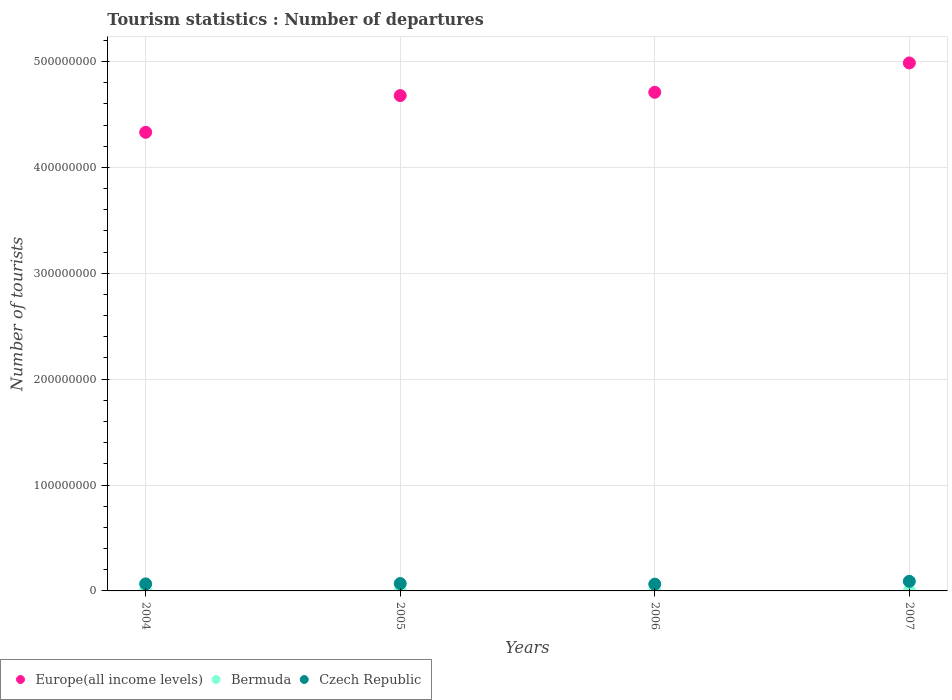How many different coloured dotlines are there?
Your response must be concise. 3. Is the number of dotlines equal to the number of legend labels?
Your answer should be very brief. Yes. What is the number of tourist departures in Europe(all income levels) in 2007?
Provide a short and direct response. 4.99e+08. Across all years, what is the maximum number of tourist departures in Bermuda?
Give a very brief answer. 1.81e+05. Across all years, what is the minimum number of tourist departures in Europe(all income levels)?
Make the answer very short. 4.33e+08. In which year was the number of tourist departures in Czech Republic maximum?
Provide a succinct answer. 2007. In which year was the number of tourist departures in Europe(all income levels) minimum?
Ensure brevity in your answer.  2004. What is the total number of tourist departures in Europe(all income levels) in the graph?
Ensure brevity in your answer.  1.87e+09. What is the difference between the number of tourist departures in Bermuda in 2004 and that in 2006?
Offer a very short reply. -1.40e+04. What is the difference between the number of tourist departures in Czech Republic in 2006 and the number of tourist departures in Bermuda in 2005?
Make the answer very short. 6.23e+06. What is the average number of tourist departures in Bermuda per year?
Your answer should be compact. 1.67e+05. In the year 2005, what is the difference between the number of tourist departures in Bermuda and number of tourist departures in Czech Republic?
Your answer should be compact. -6.80e+06. In how many years, is the number of tourist departures in Bermuda greater than 120000000?
Offer a very short reply. 0. What is the ratio of the number of tourist departures in Europe(all income levels) in 2005 to that in 2007?
Keep it short and to the point. 0.94. Is the difference between the number of tourist departures in Bermuda in 2005 and 2006 greater than the difference between the number of tourist departures in Czech Republic in 2005 and 2006?
Give a very brief answer. No. What is the difference between the highest and the second highest number of tourist departures in Bermuda?
Keep it short and to the point. 1.10e+04. What is the difference between the highest and the lowest number of tourist departures in Czech Republic?
Provide a succinct answer. 2.66e+06. In how many years, is the number of tourist departures in Czech Republic greater than the average number of tourist departures in Czech Republic taken over all years?
Give a very brief answer. 1. Is the sum of the number of tourist departures in Bermuda in 2005 and 2006 greater than the maximum number of tourist departures in Czech Republic across all years?
Provide a succinct answer. No. Is the number of tourist departures in Czech Republic strictly less than the number of tourist departures in Bermuda over the years?
Ensure brevity in your answer.  No. How many years are there in the graph?
Provide a short and direct response. 4. What is the difference between two consecutive major ticks on the Y-axis?
Make the answer very short. 1.00e+08. Does the graph contain grids?
Give a very brief answer. Yes. Where does the legend appear in the graph?
Your response must be concise. Bottom left. What is the title of the graph?
Provide a succinct answer. Tourism statistics : Number of departures. What is the label or title of the Y-axis?
Make the answer very short. Number of tourists. What is the Number of tourists in Europe(all income levels) in 2004?
Provide a short and direct response. 4.33e+08. What is the Number of tourists in Bermuda in 2004?
Offer a very short reply. 1.56e+05. What is the Number of tourists of Czech Republic in 2004?
Make the answer very short. 6.64e+06. What is the Number of tourists of Europe(all income levels) in 2005?
Provide a short and direct response. 4.68e+08. What is the Number of tourists of Bermuda in 2005?
Make the answer very short. 1.61e+05. What is the Number of tourists in Czech Republic in 2005?
Make the answer very short. 6.96e+06. What is the Number of tourists of Europe(all income levels) in 2006?
Offer a terse response. 4.71e+08. What is the Number of tourists in Czech Republic in 2006?
Ensure brevity in your answer.  6.39e+06. What is the Number of tourists of Europe(all income levels) in 2007?
Ensure brevity in your answer.  4.99e+08. What is the Number of tourists of Bermuda in 2007?
Your answer should be compact. 1.81e+05. What is the Number of tourists of Czech Republic in 2007?
Provide a short and direct response. 9.05e+06. Across all years, what is the maximum Number of tourists in Europe(all income levels)?
Offer a terse response. 4.99e+08. Across all years, what is the maximum Number of tourists of Bermuda?
Provide a short and direct response. 1.81e+05. Across all years, what is the maximum Number of tourists in Czech Republic?
Provide a succinct answer. 9.05e+06. Across all years, what is the minimum Number of tourists of Europe(all income levels)?
Your answer should be very brief. 4.33e+08. Across all years, what is the minimum Number of tourists of Bermuda?
Ensure brevity in your answer.  1.56e+05. Across all years, what is the minimum Number of tourists of Czech Republic?
Provide a short and direct response. 6.39e+06. What is the total Number of tourists in Europe(all income levels) in the graph?
Your answer should be compact. 1.87e+09. What is the total Number of tourists of Bermuda in the graph?
Your answer should be very brief. 6.68e+05. What is the total Number of tourists of Czech Republic in the graph?
Your answer should be compact. 2.90e+07. What is the difference between the Number of tourists of Europe(all income levels) in 2004 and that in 2005?
Provide a succinct answer. -3.47e+07. What is the difference between the Number of tourists of Bermuda in 2004 and that in 2005?
Offer a very short reply. -5000. What is the difference between the Number of tourists of Czech Republic in 2004 and that in 2005?
Offer a very short reply. -3.20e+05. What is the difference between the Number of tourists of Europe(all income levels) in 2004 and that in 2006?
Give a very brief answer. -3.78e+07. What is the difference between the Number of tourists in Bermuda in 2004 and that in 2006?
Give a very brief answer. -1.40e+04. What is the difference between the Number of tourists of Czech Republic in 2004 and that in 2006?
Ensure brevity in your answer.  2.50e+05. What is the difference between the Number of tourists of Europe(all income levels) in 2004 and that in 2007?
Provide a short and direct response. -6.55e+07. What is the difference between the Number of tourists of Bermuda in 2004 and that in 2007?
Make the answer very short. -2.50e+04. What is the difference between the Number of tourists in Czech Republic in 2004 and that in 2007?
Provide a succinct answer. -2.40e+06. What is the difference between the Number of tourists of Europe(all income levels) in 2005 and that in 2006?
Your response must be concise. -3.10e+06. What is the difference between the Number of tourists in Bermuda in 2005 and that in 2006?
Provide a short and direct response. -9000. What is the difference between the Number of tourists of Czech Republic in 2005 and that in 2006?
Your answer should be very brief. 5.70e+05. What is the difference between the Number of tourists in Europe(all income levels) in 2005 and that in 2007?
Provide a succinct answer. -3.08e+07. What is the difference between the Number of tourists in Bermuda in 2005 and that in 2007?
Your answer should be compact. -2.00e+04. What is the difference between the Number of tourists of Czech Republic in 2005 and that in 2007?
Offer a very short reply. -2.08e+06. What is the difference between the Number of tourists in Europe(all income levels) in 2006 and that in 2007?
Your response must be concise. -2.77e+07. What is the difference between the Number of tourists of Bermuda in 2006 and that in 2007?
Offer a very short reply. -1.10e+04. What is the difference between the Number of tourists of Czech Republic in 2006 and that in 2007?
Your answer should be compact. -2.66e+06. What is the difference between the Number of tourists of Europe(all income levels) in 2004 and the Number of tourists of Bermuda in 2005?
Offer a very short reply. 4.33e+08. What is the difference between the Number of tourists of Europe(all income levels) in 2004 and the Number of tourists of Czech Republic in 2005?
Your answer should be compact. 4.26e+08. What is the difference between the Number of tourists in Bermuda in 2004 and the Number of tourists in Czech Republic in 2005?
Provide a succinct answer. -6.81e+06. What is the difference between the Number of tourists of Europe(all income levels) in 2004 and the Number of tourists of Bermuda in 2006?
Keep it short and to the point. 4.33e+08. What is the difference between the Number of tourists in Europe(all income levels) in 2004 and the Number of tourists in Czech Republic in 2006?
Your response must be concise. 4.27e+08. What is the difference between the Number of tourists in Bermuda in 2004 and the Number of tourists in Czech Republic in 2006?
Your response must be concise. -6.24e+06. What is the difference between the Number of tourists of Europe(all income levels) in 2004 and the Number of tourists of Bermuda in 2007?
Your answer should be compact. 4.33e+08. What is the difference between the Number of tourists in Europe(all income levels) in 2004 and the Number of tourists in Czech Republic in 2007?
Keep it short and to the point. 4.24e+08. What is the difference between the Number of tourists in Bermuda in 2004 and the Number of tourists in Czech Republic in 2007?
Offer a terse response. -8.89e+06. What is the difference between the Number of tourists of Europe(all income levels) in 2005 and the Number of tourists of Bermuda in 2006?
Give a very brief answer. 4.68e+08. What is the difference between the Number of tourists in Europe(all income levels) in 2005 and the Number of tourists in Czech Republic in 2006?
Make the answer very short. 4.61e+08. What is the difference between the Number of tourists of Bermuda in 2005 and the Number of tourists of Czech Republic in 2006?
Your answer should be compact. -6.23e+06. What is the difference between the Number of tourists in Europe(all income levels) in 2005 and the Number of tourists in Bermuda in 2007?
Keep it short and to the point. 4.68e+08. What is the difference between the Number of tourists of Europe(all income levels) in 2005 and the Number of tourists of Czech Republic in 2007?
Offer a terse response. 4.59e+08. What is the difference between the Number of tourists of Bermuda in 2005 and the Number of tourists of Czech Republic in 2007?
Offer a very short reply. -8.89e+06. What is the difference between the Number of tourists of Europe(all income levels) in 2006 and the Number of tourists of Bermuda in 2007?
Your answer should be compact. 4.71e+08. What is the difference between the Number of tourists in Europe(all income levels) in 2006 and the Number of tourists in Czech Republic in 2007?
Your response must be concise. 4.62e+08. What is the difference between the Number of tourists in Bermuda in 2006 and the Number of tourists in Czech Republic in 2007?
Make the answer very short. -8.88e+06. What is the average Number of tourists in Europe(all income levels) per year?
Keep it short and to the point. 4.68e+08. What is the average Number of tourists of Bermuda per year?
Provide a short and direct response. 1.67e+05. What is the average Number of tourists in Czech Republic per year?
Provide a succinct answer. 7.26e+06. In the year 2004, what is the difference between the Number of tourists in Europe(all income levels) and Number of tourists in Bermuda?
Your answer should be compact. 4.33e+08. In the year 2004, what is the difference between the Number of tourists in Europe(all income levels) and Number of tourists in Czech Republic?
Your answer should be very brief. 4.26e+08. In the year 2004, what is the difference between the Number of tourists of Bermuda and Number of tourists of Czech Republic?
Ensure brevity in your answer.  -6.49e+06. In the year 2005, what is the difference between the Number of tourists of Europe(all income levels) and Number of tourists of Bermuda?
Your answer should be very brief. 4.68e+08. In the year 2005, what is the difference between the Number of tourists of Europe(all income levels) and Number of tourists of Czech Republic?
Your answer should be compact. 4.61e+08. In the year 2005, what is the difference between the Number of tourists in Bermuda and Number of tourists in Czech Republic?
Offer a very short reply. -6.80e+06. In the year 2006, what is the difference between the Number of tourists of Europe(all income levels) and Number of tourists of Bermuda?
Provide a short and direct response. 4.71e+08. In the year 2006, what is the difference between the Number of tourists in Europe(all income levels) and Number of tourists in Czech Republic?
Your answer should be compact. 4.64e+08. In the year 2006, what is the difference between the Number of tourists in Bermuda and Number of tourists in Czech Republic?
Offer a terse response. -6.22e+06. In the year 2007, what is the difference between the Number of tourists in Europe(all income levels) and Number of tourists in Bermuda?
Provide a succinct answer. 4.98e+08. In the year 2007, what is the difference between the Number of tourists of Europe(all income levels) and Number of tourists of Czech Republic?
Offer a very short reply. 4.90e+08. In the year 2007, what is the difference between the Number of tourists of Bermuda and Number of tourists of Czech Republic?
Make the answer very short. -8.87e+06. What is the ratio of the Number of tourists of Europe(all income levels) in 2004 to that in 2005?
Provide a succinct answer. 0.93. What is the ratio of the Number of tourists in Bermuda in 2004 to that in 2005?
Your answer should be very brief. 0.97. What is the ratio of the Number of tourists of Czech Republic in 2004 to that in 2005?
Offer a terse response. 0.95. What is the ratio of the Number of tourists of Europe(all income levels) in 2004 to that in 2006?
Ensure brevity in your answer.  0.92. What is the ratio of the Number of tourists in Bermuda in 2004 to that in 2006?
Your answer should be compact. 0.92. What is the ratio of the Number of tourists of Czech Republic in 2004 to that in 2006?
Provide a succinct answer. 1.04. What is the ratio of the Number of tourists of Europe(all income levels) in 2004 to that in 2007?
Your answer should be very brief. 0.87. What is the ratio of the Number of tourists of Bermuda in 2004 to that in 2007?
Provide a succinct answer. 0.86. What is the ratio of the Number of tourists of Czech Republic in 2004 to that in 2007?
Your response must be concise. 0.73. What is the ratio of the Number of tourists of Bermuda in 2005 to that in 2006?
Provide a succinct answer. 0.95. What is the ratio of the Number of tourists in Czech Republic in 2005 to that in 2006?
Your answer should be very brief. 1.09. What is the ratio of the Number of tourists of Europe(all income levels) in 2005 to that in 2007?
Ensure brevity in your answer.  0.94. What is the ratio of the Number of tourists of Bermuda in 2005 to that in 2007?
Offer a terse response. 0.89. What is the ratio of the Number of tourists of Czech Republic in 2005 to that in 2007?
Provide a succinct answer. 0.77. What is the ratio of the Number of tourists of Bermuda in 2006 to that in 2007?
Provide a succinct answer. 0.94. What is the ratio of the Number of tourists of Czech Republic in 2006 to that in 2007?
Keep it short and to the point. 0.71. What is the difference between the highest and the second highest Number of tourists in Europe(all income levels)?
Your response must be concise. 2.77e+07. What is the difference between the highest and the second highest Number of tourists in Bermuda?
Your answer should be compact. 1.10e+04. What is the difference between the highest and the second highest Number of tourists in Czech Republic?
Offer a terse response. 2.08e+06. What is the difference between the highest and the lowest Number of tourists of Europe(all income levels)?
Provide a succinct answer. 6.55e+07. What is the difference between the highest and the lowest Number of tourists in Bermuda?
Ensure brevity in your answer.  2.50e+04. What is the difference between the highest and the lowest Number of tourists in Czech Republic?
Offer a very short reply. 2.66e+06. 